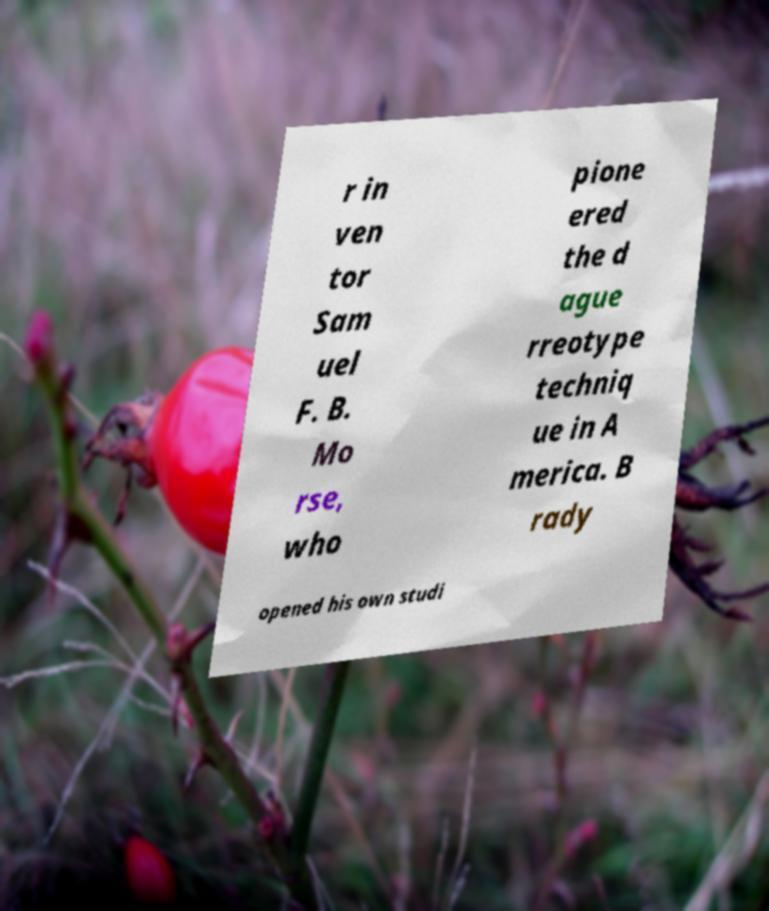Could you assist in decoding the text presented in this image and type it out clearly? r in ven tor Sam uel F. B. Mo rse, who pione ered the d ague rreotype techniq ue in A merica. B rady opened his own studi 